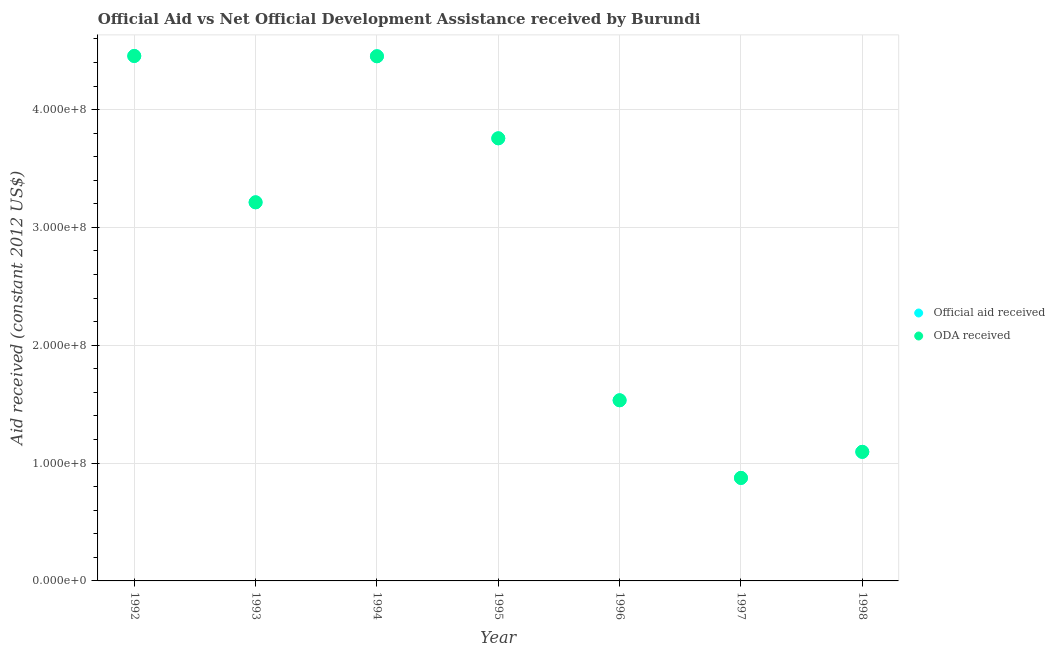What is the official aid received in 1994?
Offer a very short reply. 4.45e+08. Across all years, what is the maximum official aid received?
Give a very brief answer. 4.45e+08. Across all years, what is the minimum oda received?
Make the answer very short. 8.74e+07. In which year was the oda received maximum?
Offer a very short reply. 1992. What is the total official aid received in the graph?
Offer a very short reply. 1.94e+09. What is the difference between the official aid received in 1994 and that in 1998?
Make the answer very short. 3.36e+08. What is the difference between the oda received in 1997 and the official aid received in 1994?
Keep it short and to the point. -3.58e+08. What is the average official aid received per year?
Give a very brief answer. 2.77e+08. In the year 1998, what is the difference between the official aid received and oda received?
Your response must be concise. 0. What is the ratio of the official aid received in 1996 to that in 1997?
Provide a succinct answer. 1.75. What is the difference between the highest and the second highest official aid received?
Keep it short and to the point. 2.40e+05. What is the difference between the highest and the lowest oda received?
Offer a terse response. 3.58e+08. Does the official aid received monotonically increase over the years?
Your answer should be very brief. No. Is the oda received strictly greater than the official aid received over the years?
Provide a succinct answer. No. Is the official aid received strictly less than the oda received over the years?
Your response must be concise. No. How many years are there in the graph?
Keep it short and to the point. 7. What is the difference between two consecutive major ticks on the Y-axis?
Offer a terse response. 1.00e+08. Does the graph contain any zero values?
Keep it short and to the point. No. Does the graph contain grids?
Provide a short and direct response. Yes. Where does the legend appear in the graph?
Provide a short and direct response. Center right. How many legend labels are there?
Offer a very short reply. 2. How are the legend labels stacked?
Ensure brevity in your answer.  Vertical. What is the title of the graph?
Offer a very short reply. Official Aid vs Net Official Development Assistance received by Burundi . What is the label or title of the Y-axis?
Keep it short and to the point. Aid received (constant 2012 US$). What is the Aid received (constant 2012 US$) in Official aid received in 1992?
Make the answer very short. 4.45e+08. What is the Aid received (constant 2012 US$) in ODA received in 1992?
Offer a very short reply. 4.45e+08. What is the Aid received (constant 2012 US$) in Official aid received in 1993?
Offer a very short reply. 3.21e+08. What is the Aid received (constant 2012 US$) of ODA received in 1993?
Provide a succinct answer. 3.21e+08. What is the Aid received (constant 2012 US$) of Official aid received in 1994?
Provide a short and direct response. 4.45e+08. What is the Aid received (constant 2012 US$) of ODA received in 1994?
Give a very brief answer. 4.45e+08. What is the Aid received (constant 2012 US$) of Official aid received in 1995?
Your answer should be compact. 3.76e+08. What is the Aid received (constant 2012 US$) of ODA received in 1995?
Offer a very short reply. 3.76e+08. What is the Aid received (constant 2012 US$) of Official aid received in 1996?
Keep it short and to the point. 1.53e+08. What is the Aid received (constant 2012 US$) of ODA received in 1996?
Your answer should be very brief. 1.53e+08. What is the Aid received (constant 2012 US$) in Official aid received in 1997?
Offer a very short reply. 8.74e+07. What is the Aid received (constant 2012 US$) in ODA received in 1997?
Keep it short and to the point. 8.74e+07. What is the Aid received (constant 2012 US$) in Official aid received in 1998?
Provide a succinct answer. 1.10e+08. What is the Aid received (constant 2012 US$) of ODA received in 1998?
Make the answer very short. 1.10e+08. Across all years, what is the maximum Aid received (constant 2012 US$) in Official aid received?
Keep it short and to the point. 4.45e+08. Across all years, what is the maximum Aid received (constant 2012 US$) in ODA received?
Your answer should be compact. 4.45e+08. Across all years, what is the minimum Aid received (constant 2012 US$) of Official aid received?
Your response must be concise. 8.74e+07. Across all years, what is the minimum Aid received (constant 2012 US$) in ODA received?
Your answer should be compact. 8.74e+07. What is the total Aid received (constant 2012 US$) in Official aid received in the graph?
Keep it short and to the point. 1.94e+09. What is the total Aid received (constant 2012 US$) in ODA received in the graph?
Offer a very short reply. 1.94e+09. What is the difference between the Aid received (constant 2012 US$) in Official aid received in 1992 and that in 1993?
Your answer should be very brief. 1.24e+08. What is the difference between the Aid received (constant 2012 US$) in ODA received in 1992 and that in 1993?
Give a very brief answer. 1.24e+08. What is the difference between the Aid received (constant 2012 US$) of Official aid received in 1992 and that in 1994?
Provide a succinct answer. 2.40e+05. What is the difference between the Aid received (constant 2012 US$) of ODA received in 1992 and that in 1994?
Offer a terse response. 2.40e+05. What is the difference between the Aid received (constant 2012 US$) of Official aid received in 1992 and that in 1995?
Ensure brevity in your answer.  6.99e+07. What is the difference between the Aid received (constant 2012 US$) in ODA received in 1992 and that in 1995?
Your answer should be very brief. 6.99e+07. What is the difference between the Aid received (constant 2012 US$) of Official aid received in 1992 and that in 1996?
Provide a short and direct response. 2.92e+08. What is the difference between the Aid received (constant 2012 US$) of ODA received in 1992 and that in 1996?
Your answer should be compact. 2.92e+08. What is the difference between the Aid received (constant 2012 US$) in Official aid received in 1992 and that in 1997?
Your answer should be very brief. 3.58e+08. What is the difference between the Aid received (constant 2012 US$) of ODA received in 1992 and that in 1997?
Your response must be concise. 3.58e+08. What is the difference between the Aid received (constant 2012 US$) in Official aid received in 1992 and that in 1998?
Make the answer very short. 3.36e+08. What is the difference between the Aid received (constant 2012 US$) of ODA received in 1992 and that in 1998?
Offer a terse response. 3.36e+08. What is the difference between the Aid received (constant 2012 US$) of Official aid received in 1993 and that in 1994?
Your answer should be very brief. -1.24e+08. What is the difference between the Aid received (constant 2012 US$) of ODA received in 1993 and that in 1994?
Keep it short and to the point. -1.24e+08. What is the difference between the Aid received (constant 2012 US$) in Official aid received in 1993 and that in 1995?
Keep it short and to the point. -5.43e+07. What is the difference between the Aid received (constant 2012 US$) in ODA received in 1993 and that in 1995?
Offer a terse response. -5.43e+07. What is the difference between the Aid received (constant 2012 US$) of Official aid received in 1993 and that in 1996?
Give a very brief answer. 1.68e+08. What is the difference between the Aid received (constant 2012 US$) in ODA received in 1993 and that in 1996?
Make the answer very short. 1.68e+08. What is the difference between the Aid received (constant 2012 US$) in Official aid received in 1993 and that in 1997?
Provide a succinct answer. 2.34e+08. What is the difference between the Aid received (constant 2012 US$) of ODA received in 1993 and that in 1997?
Keep it short and to the point. 2.34e+08. What is the difference between the Aid received (constant 2012 US$) of Official aid received in 1993 and that in 1998?
Provide a short and direct response. 2.12e+08. What is the difference between the Aid received (constant 2012 US$) of ODA received in 1993 and that in 1998?
Make the answer very short. 2.12e+08. What is the difference between the Aid received (constant 2012 US$) in Official aid received in 1994 and that in 1995?
Give a very brief answer. 6.96e+07. What is the difference between the Aid received (constant 2012 US$) of ODA received in 1994 and that in 1995?
Provide a short and direct response. 6.96e+07. What is the difference between the Aid received (constant 2012 US$) in Official aid received in 1994 and that in 1996?
Offer a very short reply. 2.92e+08. What is the difference between the Aid received (constant 2012 US$) in ODA received in 1994 and that in 1996?
Keep it short and to the point. 2.92e+08. What is the difference between the Aid received (constant 2012 US$) of Official aid received in 1994 and that in 1997?
Your answer should be very brief. 3.58e+08. What is the difference between the Aid received (constant 2012 US$) of ODA received in 1994 and that in 1997?
Your answer should be compact. 3.58e+08. What is the difference between the Aid received (constant 2012 US$) of Official aid received in 1994 and that in 1998?
Keep it short and to the point. 3.36e+08. What is the difference between the Aid received (constant 2012 US$) in ODA received in 1994 and that in 1998?
Make the answer very short. 3.36e+08. What is the difference between the Aid received (constant 2012 US$) of Official aid received in 1995 and that in 1996?
Keep it short and to the point. 2.22e+08. What is the difference between the Aid received (constant 2012 US$) of ODA received in 1995 and that in 1996?
Make the answer very short. 2.22e+08. What is the difference between the Aid received (constant 2012 US$) in Official aid received in 1995 and that in 1997?
Provide a short and direct response. 2.88e+08. What is the difference between the Aid received (constant 2012 US$) in ODA received in 1995 and that in 1997?
Give a very brief answer. 2.88e+08. What is the difference between the Aid received (constant 2012 US$) in Official aid received in 1995 and that in 1998?
Your answer should be compact. 2.66e+08. What is the difference between the Aid received (constant 2012 US$) in ODA received in 1995 and that in 1998?
Provide a short and direct response. 2.66e+08. What is the difference between the Aid received (constant 2012 US$) of Official aid received in 1996 and that in 1997?
Make the answer very short. 6.59e+07. What is the difference between the Aid received (constant 2012 US$) in ODA received in 1996 and that in 1997?
Keep it short and to the point. 6.59e+07. What is the difference between the Aid received (constant 2012 US$) of Official aid received in 1996 and that in 1998?
Offer a terse response. 4.38e+07. What is the difference between the Aid received (constant 2012 US$) in ODA received in 1996 and that in 1998?
Your response must be concise. 4.38e+07. What is the difference between the Aid received (constant 2012 US$) in Official aid received in 1997 and that in 1998?
Your answer should be very brief. -2.21e+07. What is the difference between the Aid received (constant 2012 US$) in ODA received in 1997 and that in 1998?
Give a very brief answer. -2.21e+07. What is the difference between the Aid received (constant 2012 US$) of Official aid received in 1992 and the Aid received (constant 2012 US$) of ODA received in 1993?
Offer a very short reply. 1.24e+08. What is the difference between the Aid received (constant 2012 US$) in Official aid received in 1992 and the Aid received (constant 2012 US$) in ODA received in 1995?
Your answer should be compact. 6.99e+07. What is the difference between the Aid received (constant 2012 US$) of Official aid received in 1992 and the Aid received (constant 2012 US$) of ODA received in 1996?
Give a very brief answer. 2.92e+08. What is the difference between the Aid received (constant 2012 US$) in Official aid received in 1992 and the Aid received (constant 2012 US$) in ODA received in 1997?
Your answer should be very brief. 3.58e+08. What is the difference between the Aid received (constant 2012 US$) of Official aid received in 1992 and the Aid received (constant 2012 US$) of ODA received in 1998?
Provide a short and direct response. 3.36e+08. What is the difference between the Aid received (constant 2012 US$) of Official aid received in 1993 and the Aid received (constant 2012 US$) of ODA received in 1994?
Give a very brief answer. -1.24e+08. What is the difference between the Aid received (constant 2012 US$) of Official aid received in 1993 and the Aid received (constant 2012 US$) of ODA received in 1995?
Your answer should be compact. -5.43e+07. What is the difference between the Aid received (constant 2012 US$) of Official aid received in 1993 and the Aid received (constant 2012 US$) of ODA received in 1996?
Provide a succinct answer. 1.68e+08. What is the difference between the Aid received (constant 2012 US$) of Official aid received in 1993 and the Aid received (constant 2012 US$) of ODA received in 1997?
Keep it short and to the point. 2.34e+08. What is the difference between the Aid received (constant 2012 US$) in Official aid received in 1993 and the Aid received (constant 2012 US$) in ODA received in 1998?
Make the answer very short. 2.12e+08. What is the difference between the Aid received (constant 2012 US$) of Official aid received in 1994 and the Aid received (constant 2012 US$) of ODA received in 1995?
Provide a succinct answer. 6.96e+07. What is the difference between the Aid received (constant 2012 US$) of Official aid received in 1994 and the Aid received (constant 2012 US$) of ODA received in 1996?
Offer a terse response. 2.92e+08. What is the difference between the Aid received (constant 2012 US$) of Official aid received in 1994 and the Aid received (constant 2012 US$) of ODA received in 1997?
Offer a terse response. 3.58e+08. What is the difference between the Aid received (constant 2012 US$) in Official aid received in 1994 and the Aid received (constant 2012 US$) in ODA received in 1998?
Provide a short and direct response. 3.36e+08. What is the difference between the Aid received (constant 2012 US$) of Official aid received in 1995 and the Aid received (constant 2012 US$) of ODA received in 1996?
Ensure brevity in your answer.  2.22e+08. What is the difference between the Aid received (constant 2012 US$) of Official aid received in 1995 and the Aid received (constant 2012 US$) of ODA received in 1997?
Your answer should be very brief. 2.88e+08. What is the difference between the Aid received (constant 2012 US$) of Official aid received in 1995 and the Aid received (constant 2012 US$) of ODA received in 1998?
Make the answer very short. 2.66e+08. What is the difference between the Aid received (constant 2012 US$) in Official aid received in 1996 and the Aid received (constant 2012 US$) in ODA received in 1997?
Give a very brief answer. 6.59e+07. What is the difference between the Aid received (constant 2012 US$) of Official aid received in 1996 and the Aid received (constant 2012 US$) of ODA received in 1998?
Offer a very short reply. 4.38e+07. What is the difference between the Aid received (constant 2012 US$) of Official aid received in 1997 and the Aid received (constant 2012 US$) of ODA received in 1998?
Ensure brevity in your answer.  -2.21e+07. What is the average Aid received (constant 2012 US$) in Official aid received per year?
Give a very brief answer. 2.77e+08. What is the average Aid received (constant 2012 US$) in ODA received per year?
Give a very brief answer. 2.77e+08. In the year 1992, what is the difference between the Aid received (constant 2012 US$) of Official aid received and Aid received (constant 2012 US$) of ODA received?
Ensure brevity in your answer.  0. In the year 1995, what is the difference between the Aid received (constant 2012 US$) in Official aid received and Aid received (constant 2012 US$) in ODA received?
Offer a terse response. 0. In the year 1997, what is the difference between the Aid received (constant 2012 US$) of Official aid received and Aid received (constant 2012 US$) of ODA received?
Offer a very short reply. 0. In the year 1998, what is the difference between the Aid received (constant 2012 US$) of Official aid received and Aid received (constant 2012 US$) of ODA received?
Make the answer very short. 0. What is the ratio of the Aid received (constant 2012 US$) of Official aid received in 1992 to that in 1993?
Provide a short and direct response. 1.39. What is the ratio of the Aid received (constant 2012 US$) in ODA received in 1992 to that in 1993?
Provide a succinct answer. 1.39. What is the ratio of the Aid received (constant 2012 US$) in Official aid received in 1992 to that in 1994?
Make the answer very short. 1. What is the ratio of the Aid received (constant 2012 US$) in ODA received in 1992 to that in 1994?
Provide a short and direct response. 1. What is the ratio of the Aid received (constant 2012 US$) in Official aid received in 1992 to that in 1995?
Your answer should be very brief. 1.19. What is the ratio of the Aid received (constant 2012 US$) of ODA received in 1992 to that in 1995?
Provide a short and direct response. 1.19. What is the ratio of the Aid received (constant 2012 US$) of Official aid received in 1992 to that in 1996?
Offer a terse response. 2.91. What is the ratio of the Aid received (constant 2012 US$) in ODA received in 1992 to that in 1996?
Offer a very short reply. 2.91. What is the ratio of the Aid received (constant 2012 US$) of Official aid received in 1992 to that in 1997?
Your answer should be compact. 5.1. What is the ratio of the Aid received (constant 2012 US$) of ODA received in 1992 to that in 1997?
Make the answer very short. 5.1. What is the ratio of the Aid received (constant 2012 US$) in Official aid received in 1992 to that in 1998?
Offer a very short reply. 4.07. What is the ratio of the Aid received (constant 2012 US$) of ODA received in 1992 to that in 1998?
Provide a short and direct response. 4.07. What is the ratio of the Aid received (constant 2012 US$) of Official aid received in 1993 to that in 1994?
Offer a terse response. 0.72. What is the ratio of the Aid received (constant 2012 US$) in ODA received in 1993 to that in 1994?
Offer a terse response. 0.72. What is the ratio of the Aid received (constant 2012 US$) of Official aid received in 1993 to that in 1995?
Ensure brevity in your answer.  0.86. What is the ratio of the Aid received (constant 2012 US$) in ODA received in 1993 to that in 1995?
Your answer should be compact. 0.86. What is the ratio of the Aid received (constant 2012 US$) of Official aid received in 1993 to that in 1996?
Offer a terse response. 2.1. What is the ratio of the Aid received (constant 2012 US$) in ODA received in 1993 to that in 1996?
Your response must be concise. 2.1. What is the ratio of the Aid received (constant 2012 US$) in Official aid received in 1993 to that in 1997?
Your response must be concise. 3.68. What is the ratio of the Aid received (constant 2012 US$) in ODA received in 1993 to that in 1997?
Your answer should be compact. 3.68. What is the ratio of the Aid received (constant 2012 US$) in Official aid received in 1993 to that in 1998?
Your response must be concise. 2.93. What is the ratio of the Aid received (constant 2012 US$) in ODA received in 1993 to that in 1998?
Make the answer very short. 2.93. What is the ratio of the Aid received (constant 2012 US$) of Official aid received in 1994 to that in 1995?
Your response must be concise. 1.19. What is the ratio of the Aid received (constant 2012 US$) of ODA received in 1994 to that in 1995?
Offer a very short reply. 1.19. What is the ratio of the Aid received (constant 2012 US$) of Official aid received in 1994 to that in 1996?
Your answer should be compact. 2.9. What is the ratio of the Aid received (constant 2012 US$) in ODA received in 1994 to that in 1996?
Your answer should be very brief. 2.9. What is the ratio of the Aid received (constant 2012 US$) in Official aid received in 1994 to that in 1997?
Keep it short and to the point. 5.09. What is the ratio of the Aid received (constant 2012 US$) of ODA received in 1994 to that in 1997?
Ensure brevity in your answer.  5.09. What is the ratio of the Aid received (constant 2012 US$) of Official aid received in 1994 to that in 1998?
Your response must be concise. 4.07. What is the ratio of the Aid received (constant 2012 US$) of ODA received in 1994 to that in 1998?
Provide a short and direct response. 4.07. What is the ratio of the Aid received (constant 2012 US$) of Official aid received in 1995 to that in 1996?
Ensure brevity in your answer.  2.45. What is the ratio of the Aid received (constant 2012 US$) in ODA received in 1995 to that in 1996?
Provide a succinct answer. 2.45. What is the ratio of the Aid received (constant 2012 US$) in Official aid received in 1995 to that in 1997?
Your answer should be compact. 4.3. What is the ratio of the Aid received (constant 2012 US$) in ODA received in 1995 to that in 1997?
Your response must be concise. 4.3. What is the ratio of the Aid received (constant 2012 US$) of Official aid received in 1995 to that in 1998?
Give a very brief answer. 3.43. What is the ratio of the Aid received (constant 2012 US$) in ODA received in 1995 to that in 1998?
Your response must be concise. 3.43. What is the ratio of the Aid received (constant 2012 US$) of Official aid received in 1996 to that in 1997?
Offer a very short reply. 1.75. What is the ratio of the Aid received (constant 2012 US$) of ODA received in 1996 to that in 1997?
Your answer should be very brief. 1.75. What is the ratio of the Aid received (constant 2012 US$) of Official aid received in 1996 to that in 1998?
Give a very brief answer. 1.4. What is the ratio of the Aid received (constant 2012 US$) in ODA received in 1996 to that in 1998?
Offer a very short reply. 1.4. What is the ratio of the Aid received (constant 2012 US$) of Official aid received in 1997 to that in 1998?
Your response must be concise. 0.8. What is the ratio of the Aid received (constant 2012 US$) in ODA received in 1997 to that in 1998?
Ensure brevity in your answer.  0.8. What is the difference between the highest and the second highest Aid received (constant 2012 US$) in Official aid received?
Your response must be concise. 2.40e+05. What is the difference between the highest and the second highest Aid received (constant 2012 US$) of ODA received?
Provide a short and direct response. 2.40e+05. What is the difference between the highest and the lowest Aid received (constant 2012 US$) in Official aid received?
Ensure brevity in your answer.  3.58e+08. What is the difference between the highest and the lowest Aid received (constant 2012 US$) in ODA received?
Make the answer very short. 3.58e+08. 